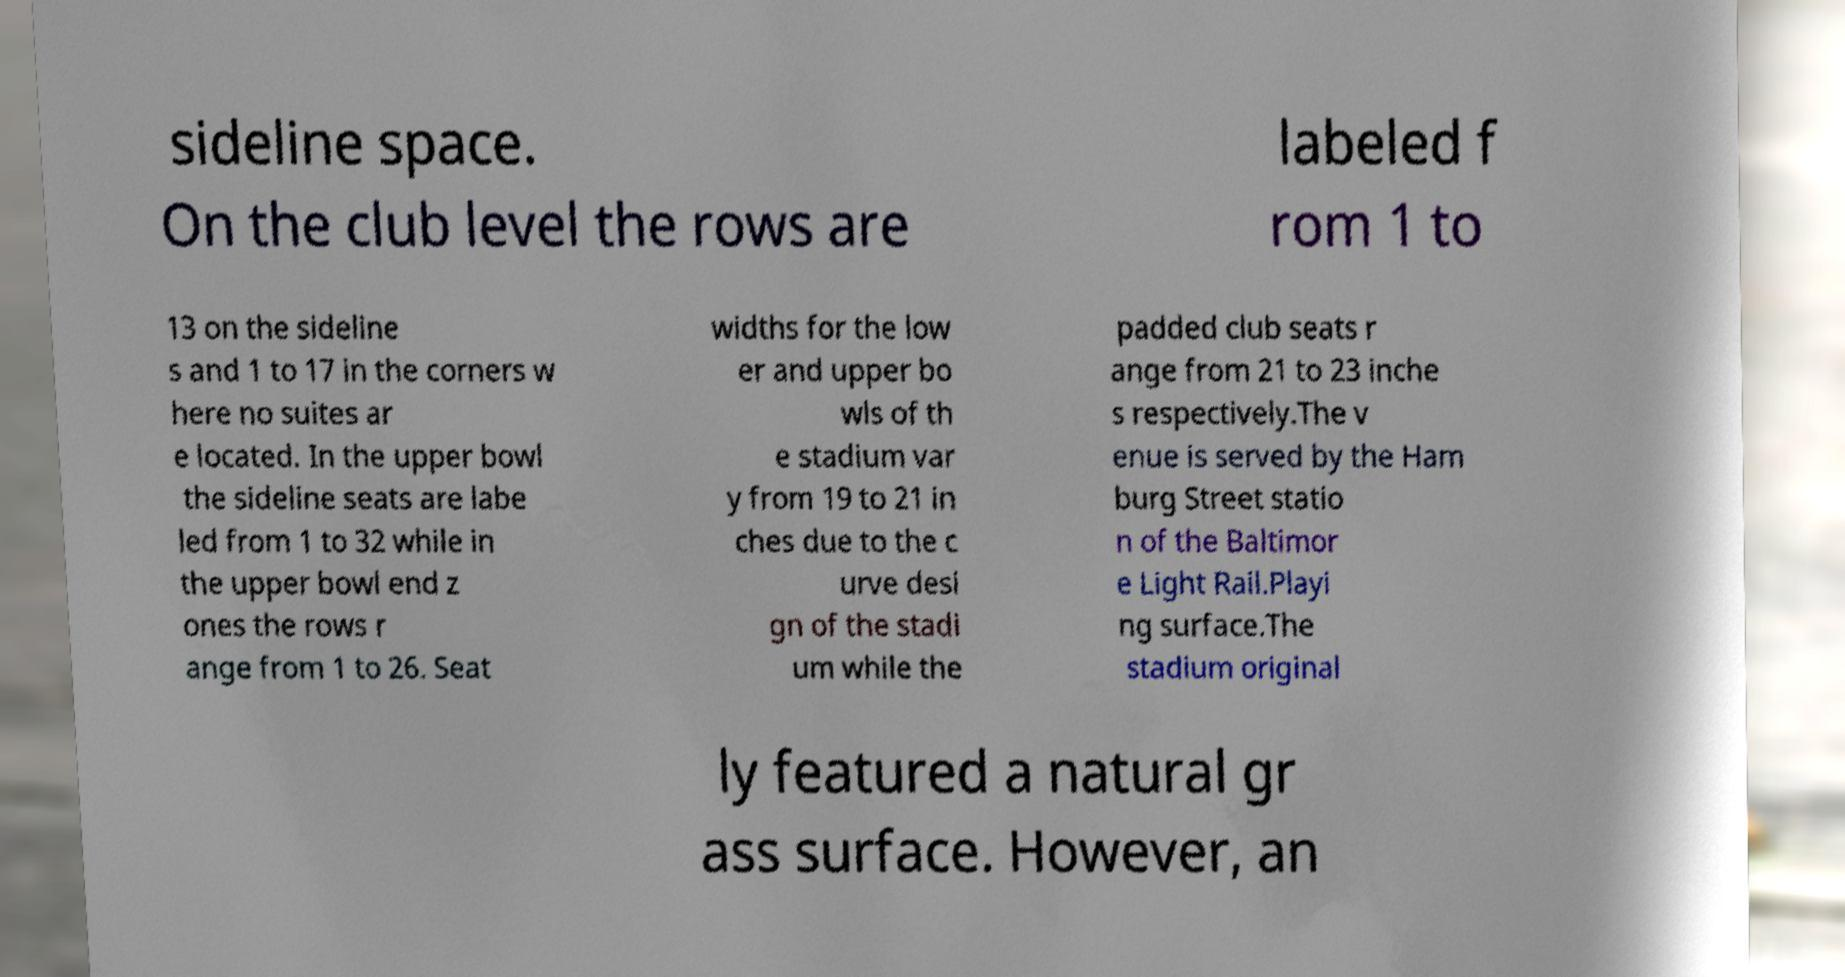Please read and relay the text visible in this image. What does it say? sideline space. On the club level the rows are labeled f rom 1 to 13 on the sideline s and 1 to 17 in the corners w here no suites ar e located. In the upper bowl the sideline seats are labe led from 1 to 32 while in the upper bowl end z ones the rows r ange from 1 to 26. Seat widths for the low er and upper bo wls of th e stadium var y from 19 to 21 in ches due to the c urve desi gn of the stadi um while the padded club seats r ange from 21 to 23 inche s respectively.The v enue is served by the Ham burg Street statio n of the Baltimor e Light Rail.Playi ng surface.The stadium original ly featured a natural gr ass surface. However, an 